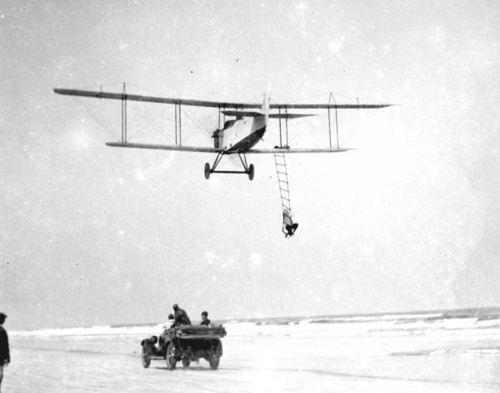Describe the objects in this image and their specific colors. I can see airplane in darkgray, gray, lightgray, and black tones, truck in darkgray, gray, black, and lightgray tones, people in darkgray, black, gray, and lightgray tones, people in darkgray, black, gray, and lightgray tones, and people in darkgray, black, gray, and lightgray tones in this image. 